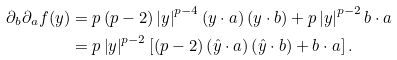Convert formula to latex. <formula><loc_0><loc_0><loc_500><loc_500>\partial _ { b } \partial _ { a } f ( y ) & = p \left ( p - 2 \right ) \left | y \right | ^ { p - 4 } \left ( y \cdot a \right ) \left ( y \cdot b \right ) + p \left | y \right | ^ { p - 2 } b \cdot a \\ & = p \left | y \right | ^ { p - 2 } \left [ \left ( p - 2 \right ) \left ( \hat { y } \cdot a \right ) \left ( \hat { y } \cdot b \right ) + b \cdot a \right ] .</formula> 